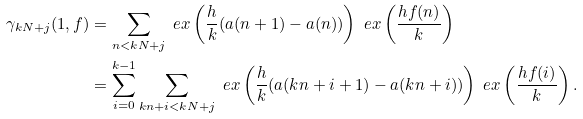<formula> <loc_0><loc_0><loc_500><loc_500>\gamma _ { k N + j } ( 1 , f ) & = \sum _ { n < k N + j } \ e x \left ( \frac { h } { k } ( a ( n + 1 ) - a ( n ) ) \right ) \ e x \left ( \frac { h f ( n ) } { k } \right ) \\ & = \sum _ { i = 0 } ^ { k - 1 } \sum _ { k n + i < k N + j } \ e x \left ( \frac { h } { k } ( a ( k n + i + 1 ) - a ( k n + i ) ) \right ) \ e x \left ( \frac { h f ( i ) } { k } \right ) .</formula> 